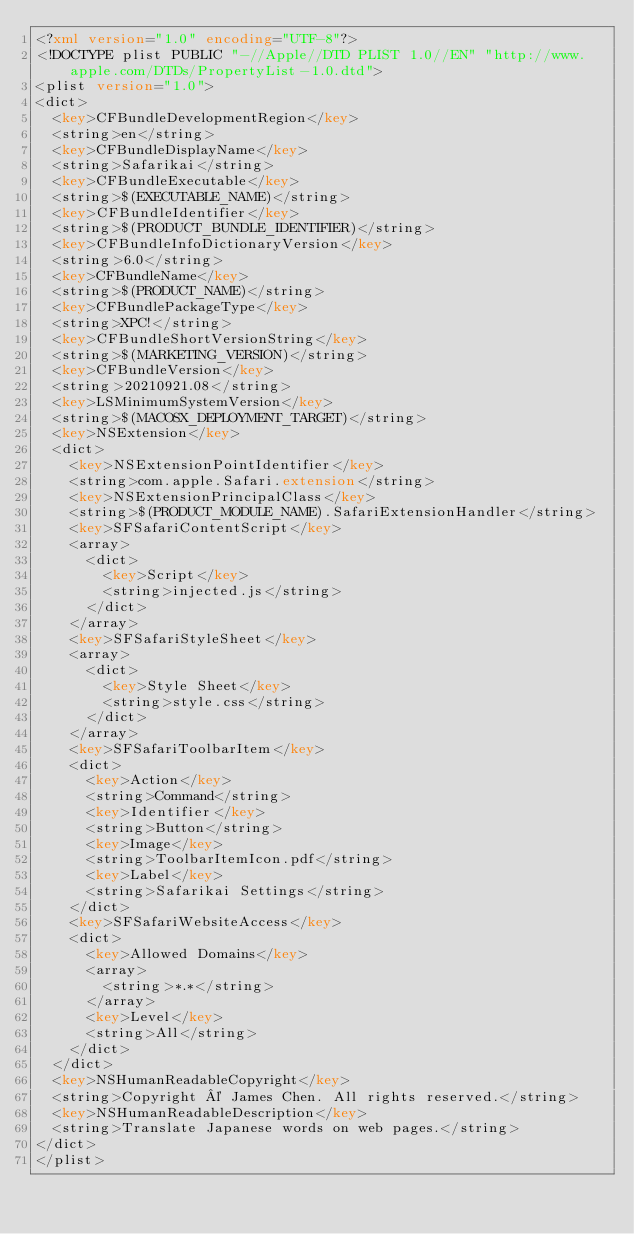<code> <loc_0><loc_0><loc_500><loc_500><_XML_><?xml version="1.0" encoding="UTF-8"?>
<!DOCTYPE plist PUBLIC "-//Apple//DTD PLIST 1.0//EN" "http://www.apple.com/DTDs/PropertyList-1.0.dtd">
<plist version="1.0">
<dict>
	<key>CFBundleDevelopmentRegion</key>
	<string>en</string>
	<key>CFBundleDisplayName</key>
	<string>Safarikai</string>
	<key>CFBundleExecutable</key>
	<string>$(EXECUTABLE_NAME)</string>
	<key>CFBundleIdentifier</key>
	<string>$(PRODUCT_BUNDLE_IDENTIFIER)</string>
	<key>CFBundleInfoDictionaryVersion</key>
	<string>6.0</string>
	<key>CFBundleName</key>
	<string>$(PRODUCT_NAME)</string>
	<key>CFBundlePackageType</key>
	<string>XPC!</string>
	<key>CFBundleShortVersionString</key>
	<string>$(MARKETING_VERSION)</string>
	<key>CFBundleVersion</key>
	<string>20210921.08</string>
	<key>LSMinimumSystemVersion</key>
	<string>$(MACOSX_DEPLOYMENT_TARGET)</string>
	<key>NSExtension</key>
	<dict>
		<key>NSExtensionPointIdentifier</key>
		<string>com.apple.Safari.extension</string>
		<key>NSExtensionPrincipalClass</key>
		<string>$(PRODUCT_MODULE_NAME).SafariExtensionHandler</string>
		<key>SFSafariContentScript</key>
		<array>
			<dict>
				<key>Script</key>
				<string>injected.js</string>
			</dict>
		</array>
		<key>SFSafariStyleSheet</key>
		<array>
			<dict>
				<key>Style Sheet</key>
				<string>style.css</string>
			</dict>
		</array>
		<key>SFSafariToolbarItem</key>
		<dict>
			<key>Action</key>
			<string>Command</string>
			<key>Identifier</key>
			<string>Button</string>
			<key>Image</key>
			<string>ToolbarItemIcon.pdf</string>
			<key>Label</key>
			<string>Safarikai Settings</string>
		</dict>
		<key>SFSafariWebsiteAccess</key>
		<dict>
			<key>Allowed Domains</key>
			<array>
				<string>*.*</string>
			</array>
			<key>Level</key>
			<string>All</string>
		</dict>
	</dict>
	<key>NSHumanReadableCopyright</key>
	<string>Copyright © James Chen. All rights reserved.</string>
	<key>NSHumanReadableDescription</key>
	<string>Translate Japanese words on web pages.</string>
</dict>
</plist>
</code> 